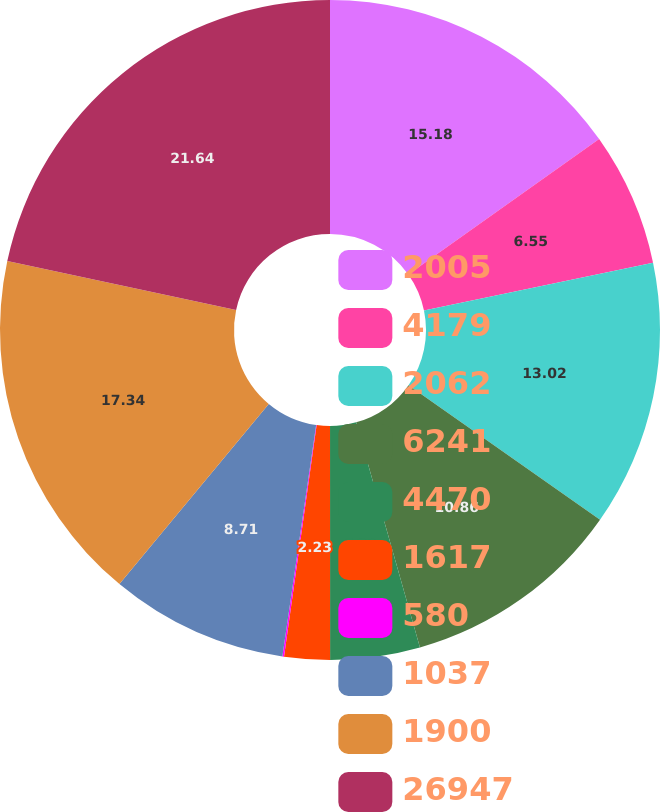Convert chart to OTSL. <chart><loc_0><loc_0><loc_500><loc_500><pie_chart><fcel>2005<fcel>4179<fcel>2062<fcel>6241<fcel>4470<fcel>1617<fcel>580<fcel>1037<fcel>1900<fcel>26947<nl><fcel>15.18%<fcel>6.55%<fcel>13.02%<fcel>10.86%<fcel>4.39%<fcel>2.23%<fcel>0.08%<fcel>8.71%<fcel>17.34%<fcel>21.65%<nl></chart> 